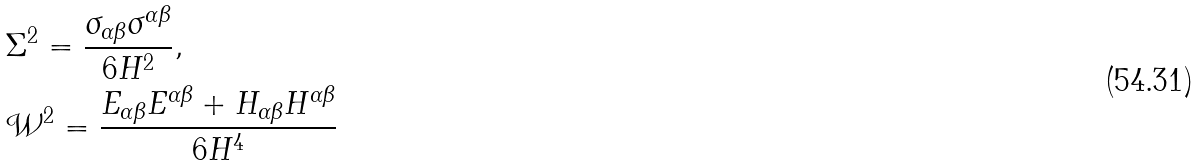Convert formula to latex. <formula><loc_0><loc_0><loc_500><loc_500>& \Sigma ^ { 2 } = \frac { \sigma _ { \alpha \beta } \sigma ^ { \alpha \beta } } { 6 H ^ { 2 } } , \\ & \mathcal { W } ^ { 2 } = \frac { E _ { \alpha \beta } E ^ { \alpha \beta } + H _ { \alpha \beta } H ^ { \alpha \beta } } { 6 H ^ { 4 } }</formula> 